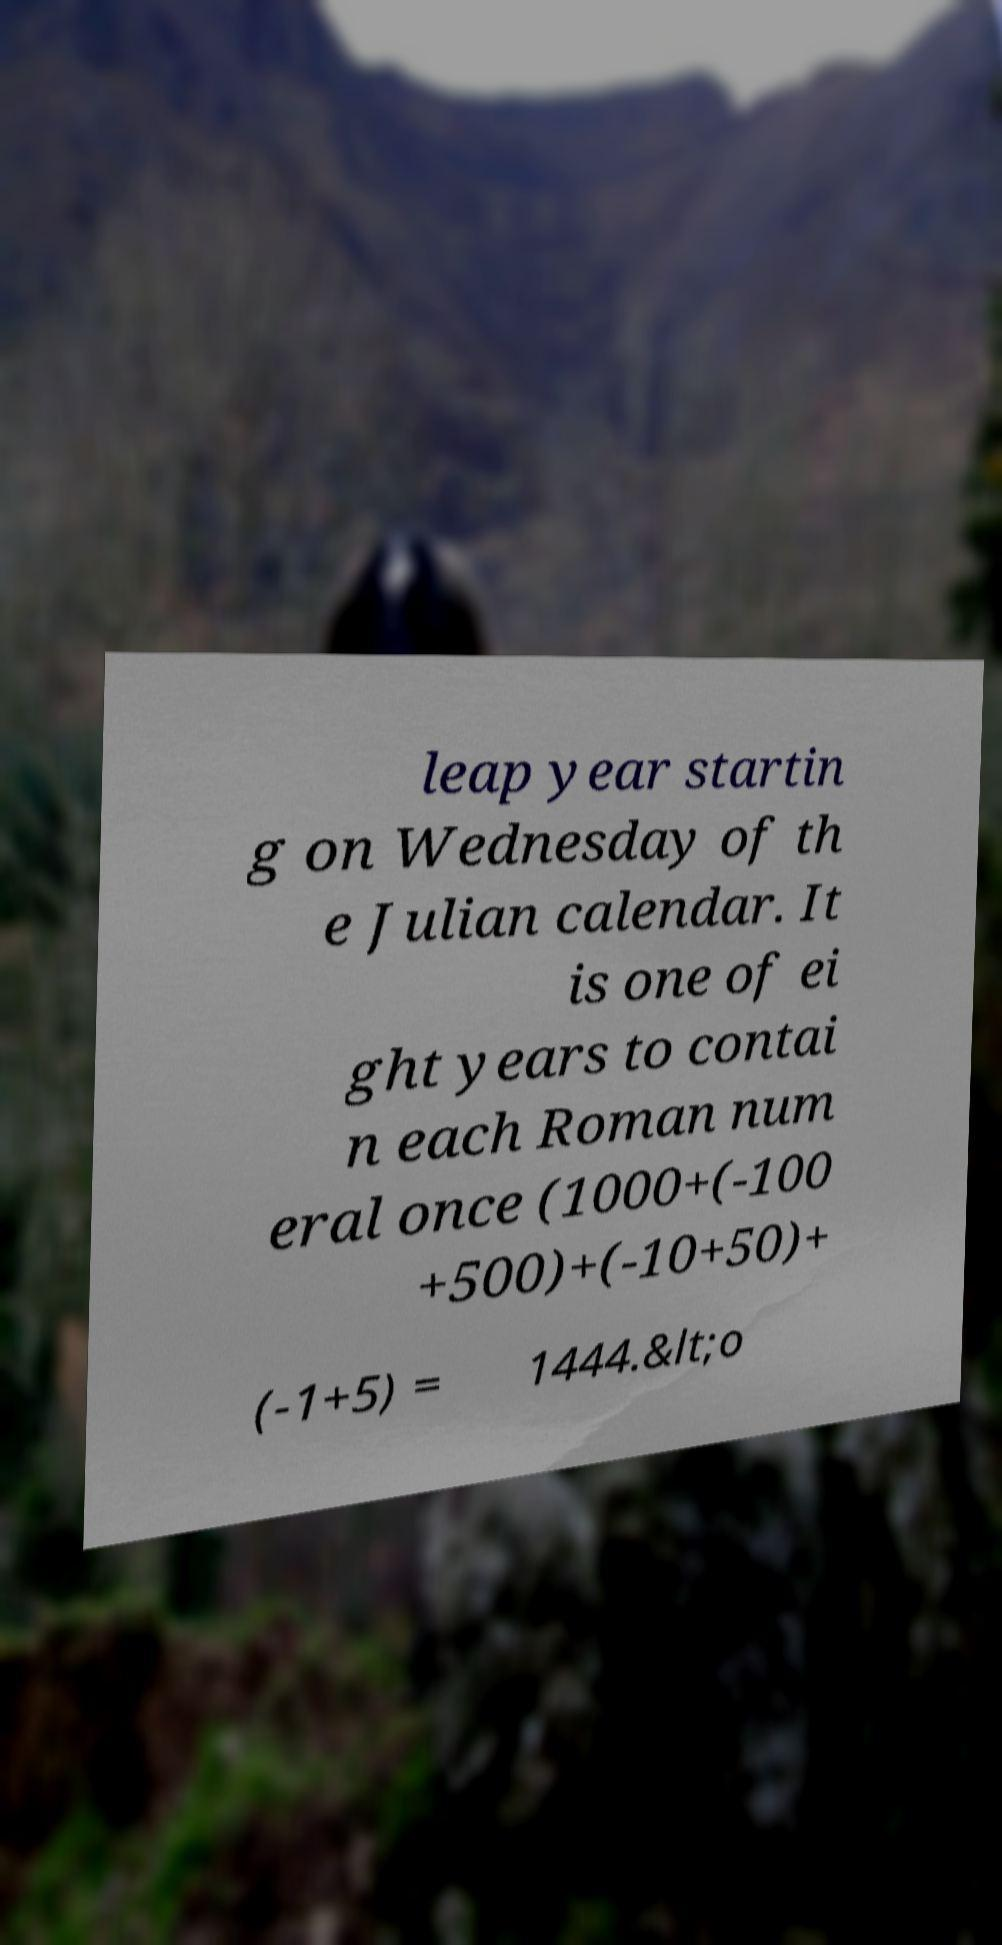For documentation purposes, I need the text within this image transcribed. Could you provide that? leap year startin g on Wednesday of th e Julian calendar. It is one of ei ght years to contai n each Roman num eral once (1000+(-100 +500)+(-10+50)+ (-1+5) = 1444.&lt;o 